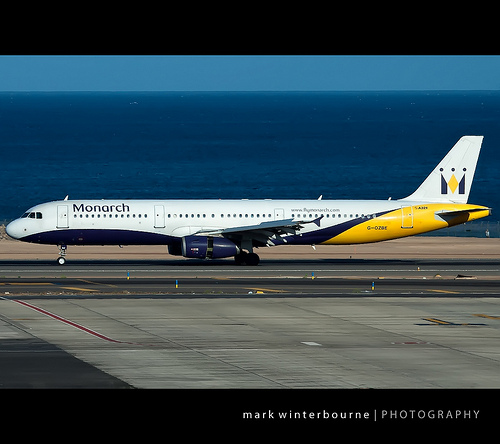Please provide a short description for this region: [0.33, 0.48, 0.55, 0.5]. A row of small windows, likely passenger windows on the body of the plane. 